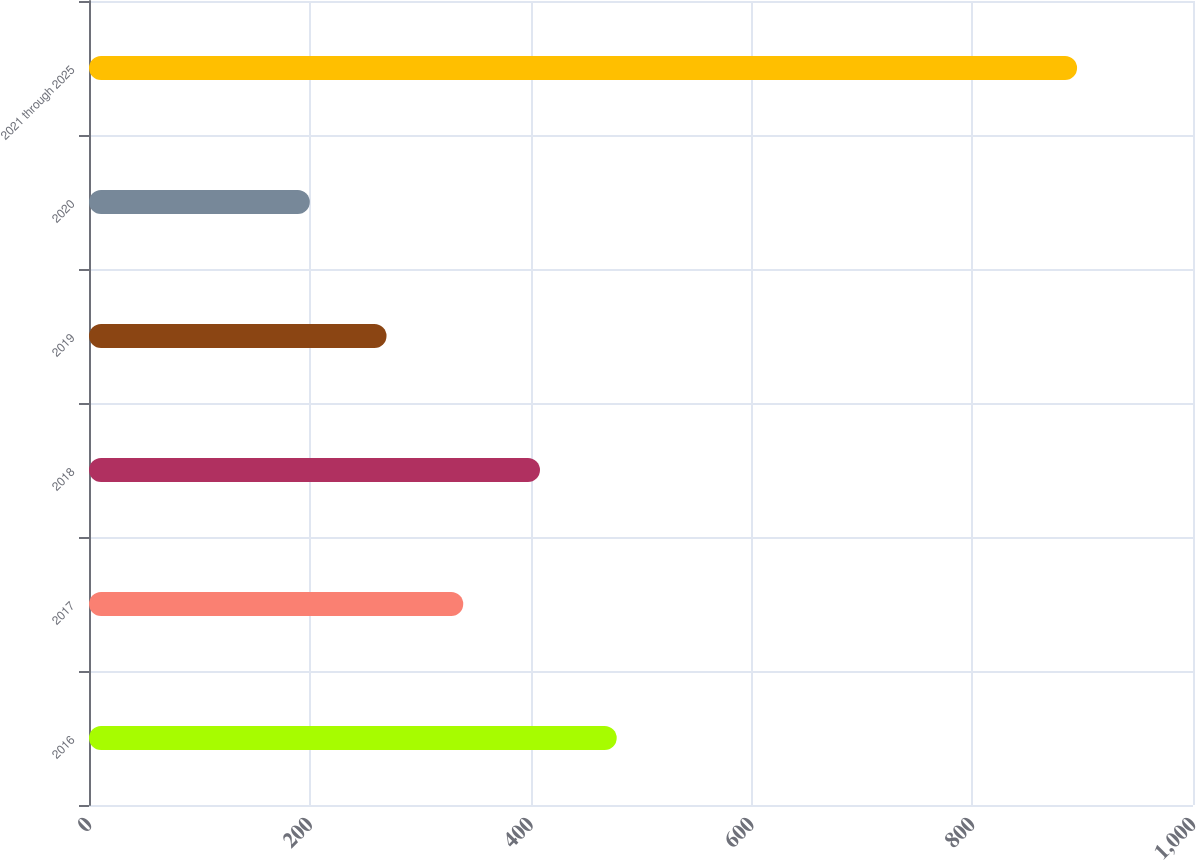Convert chart. <chart><loc_0><loc_0><loc_500><loc_500><bar_chart><fcel>2016<fcel>2017<fcel>2018<fcel>2019<fcel>2020<fcel>2021 through 2025<nl><fcel>478<fcel>339<fcel>408.5<fcel>269.5<fcel>200<fcel>895<nl></chart> 